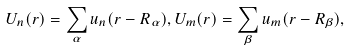<formula> <loc_0><loc_0><loc_500><loc_500>U _ { n } ( { r } ) = \sum _ { \alpha } u _ { n } ( { r } - { R } _ { \alpha } ) , U _ { m } ( { r } ) = \sum _ { \beta } u _ { m } ( { r } - { R } _ { \beta } ) ,</formula> 